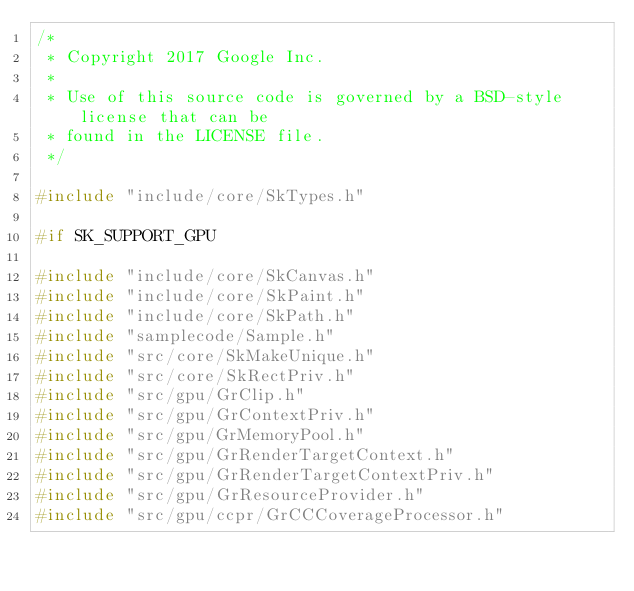<code> <loc_0><loc_0><loc_500><loc_500><_C++_>/*
 * Copyright 2017 Google Inc.
 *
 * Use of this source code is governed by a BSD-style license that can be
 * found in the LICENSE file.
 */

#include "include/core/SkTypes.h"

#if SK_SUPPORT_GPU

#include "include/core/SkCanvas.h"
#include "include/core/SkPaint.h"
#include "include/core/SkPath.h"
#include "samplecode/Sample.h"
#include "src/core/SkMakeUnique.h"
#include "src/core/SkRectPriv.h"
#include "src/gpu/GrClip.h"
#include "src/gpu/GrContextPriv.h"
#include "src/gpu/GrMemoryPool.h"
#include "src/gpu/GrRenderTargetContext.h"
#include "src/gpu/GrRenderTargetContextPriv.h"
#include "src/gpu/GrResourceProvider.h"
#include "src/gpu/ccpr/GrCCCoverageProcessor.h"</code> 